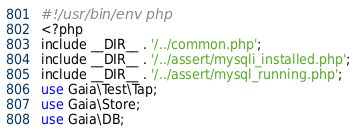<code> <loc_0><loc_0><loc_500><loc_500><_Perl_>#!/usr/bin/env php
<?php
include __DIR__ . '/../common.php';
include __DIR__ . '/../assert/mysqli_installed.php';
include __DIR__ . '/../assert/mysql_running.php';
use Gaia\Test\Tap;
use Gaia\Store;
use Gaia\DB;
</code> 